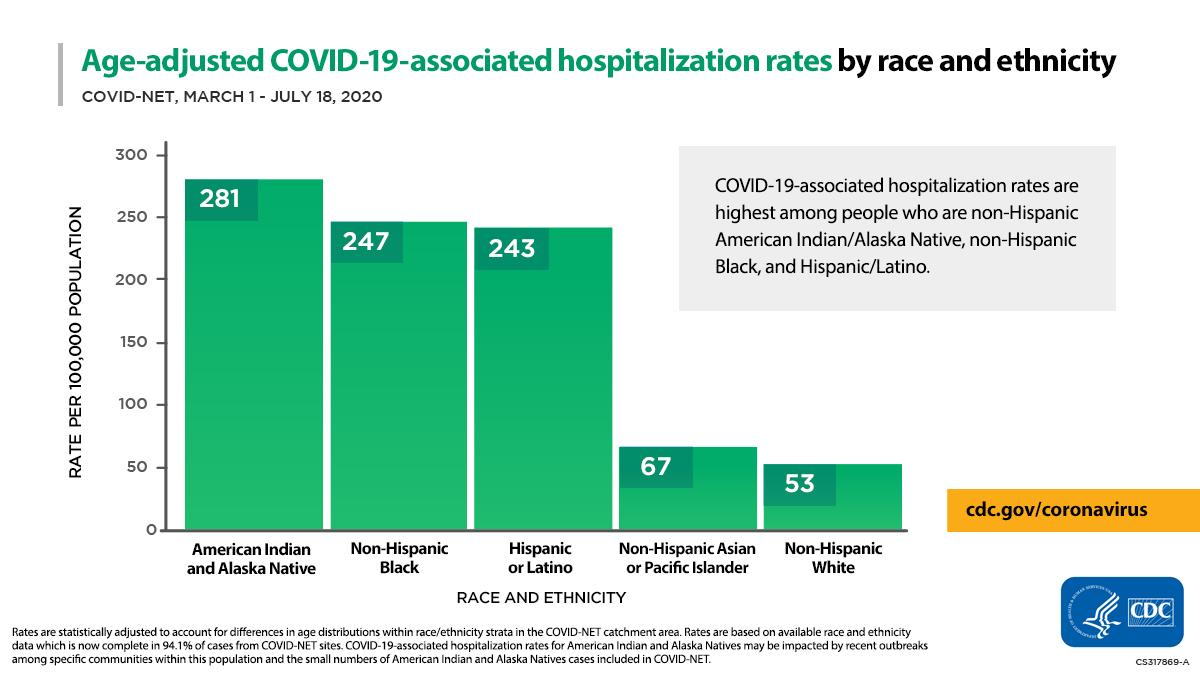List a handful of essential elements in this visual. During the first six months of the COVID-19 pandemic, the ethnicity/race that showed the lowest hospitalization rate per 100,000 population was Non-Hispanic White individuals. The COVID-19-associated hospitalization rate among non-Hispanic whites during the period of March 1-July 18, 2020 was 53 per 100,000 population. The COVID-19-associated hospitalization rate among non-Hispanic black individuals during the period of March 1 to July 18, 2020 was approximately 247 per 100,000 population. During the period of March 1-July 18, 2020, the ethnicity and race that showed the highest COVID-19-associated hospitalization rate per 100,000 population was American Indian and Alaska Native. 